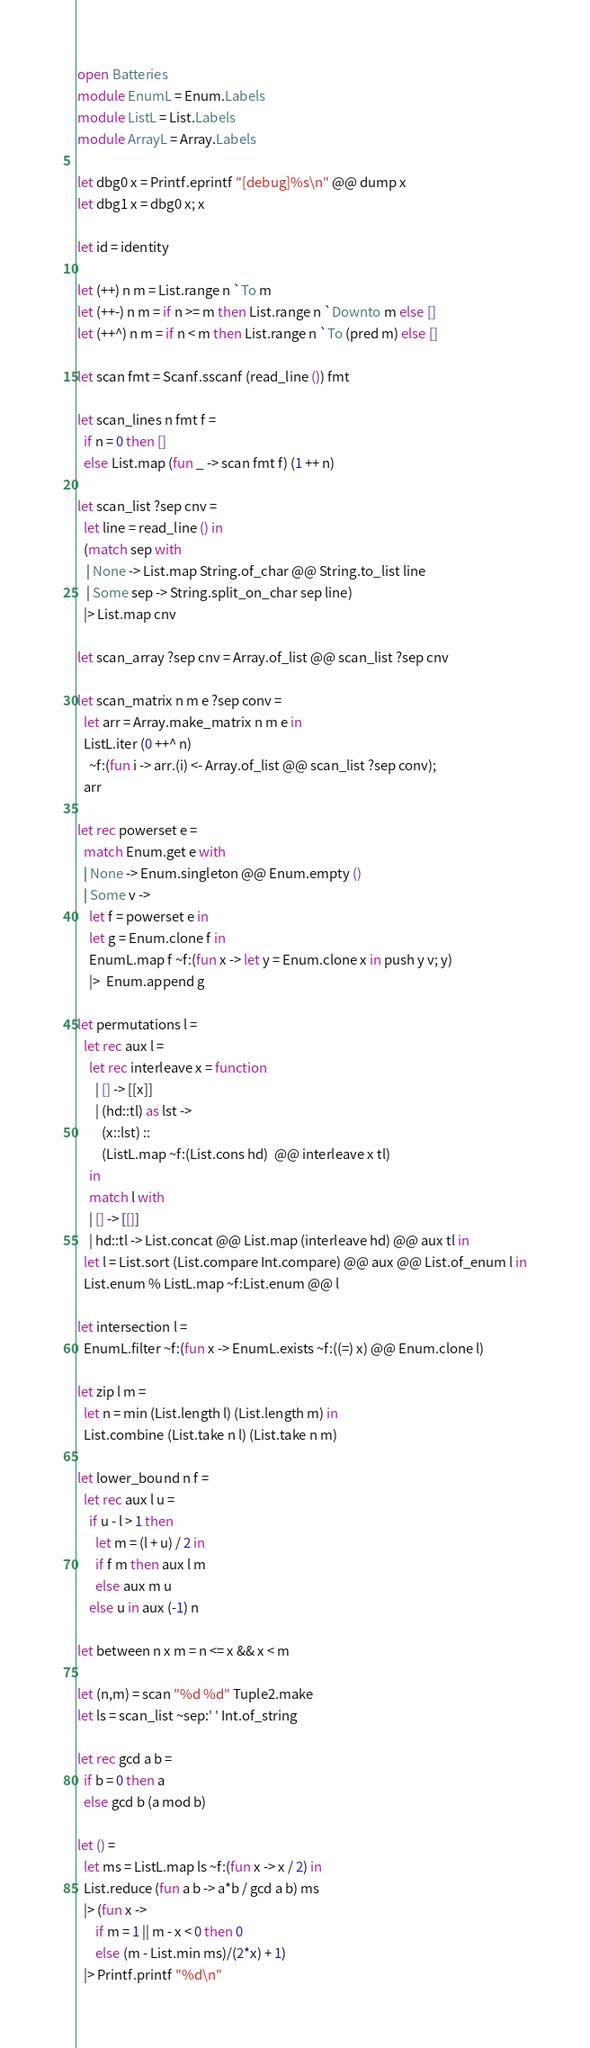<code> <loc_0><loc_0><loc_500><loc_500><_OCaml_>open Batteries
module EnumL = Enum.Labels
module ListL = List.Labels
module ArrayL = Array.Labels

let dbg0 x = Printf.eprintf "[debug]%s\n" @@ dump x
let dbg1 x = dbg0 x; x

let id = identity

let (++) n m = List.range n `To m
let (++-) n m = if n >= m then List.range n `Downto m else []
let (++^) n m = if n < m then List.range n `To (pred m) else []

let scan fmt = Scanf.sscanf (read_line ()) fmt

let scan_lines n fmt f =
  if n = 0 then []
  else List.map (fun _ -> scan fmt f) (1 ++ n)

let scan_list ?sep cnv =
  let line = read_line () in
  (match sep with
   | None -> List.map String.of_char @@ String.to_list line
   | Some sep -> String.split_on_char sep line)
  |> List.map cnv

let scan_array ?sep cnv = Array.of_list @@ scan_list ?sep cnv

let scan_matrix n m e ?sep conv =
  let arr = Array.make_matrix n m e in
  ListL.iter (0 ++^ n)
    ~f:(fun i -> arr.(i) <- Array.of_list @@ scan_list ?sep conv);
  arr

let rec powerset e =
  match Enum.get e with
  | None -> Enum.singleton @@ Enum.empty ()
  | Some v ->
    let f = powerset e in
    let g = Enum.clone f in
    EnumL.map f ~f:(fun x -> let y = Enum.clone x in push y v; y)
    |>  Enum.append g

let permutations l =
  let rec aux l =
    let rec interleave x = function
      | [] -> [[x]]
      | (hd::tl) as lst ->
        (x::lst) ::
        (ListL.map ~f:(List.cons hd)  @@ interleave x tl)
    in
    match l with
    | [] -> [[]]
    | hd::tl -> List.concat @@ List.map (interleave hd) @@ aux tl in
  let l = List.sort (List.compare Int.compare) @@ aux @@ List.of_enum l in
  List.enum % ListL.map ~f:List.enum @@ l

let intersection l =
  EnumL.filter ~f:(fun x -> EnumL.exists ~f:((=) x) @@ Enum.clone l)

let zip l m =
  let n = min (List.length l) (List.length m) in
  List.combine (List.take n l) (List.take n m)

let lower_bound n f =
  let rec aux l u =
    if u - l > 1 then
      let m = (l + u) / 2 in
      if f m then aux l m
      else aux m u
    else u in aux (-1) n

let between n x m = n <= x && x < m

let (n,m) = scan "%d %d" Tuple2.make
let ls = scan_list ~sep:' ' Int.of_string

let rec gcd a b =
  if b = 0 then a
  else gcd b (a mod b)

let () =
  let ms = ListL.map ls ~f:(fun x -> x / 2) in
  List.reduce (fun a b -> a*b / gcd a b) ms
  |> (fun x ->
      if m = 1 || m - x < 0 then 0
      else (m - List.min ms)/(2*x) + 1)
  |> Printf.printf "%d\n"
</code> 